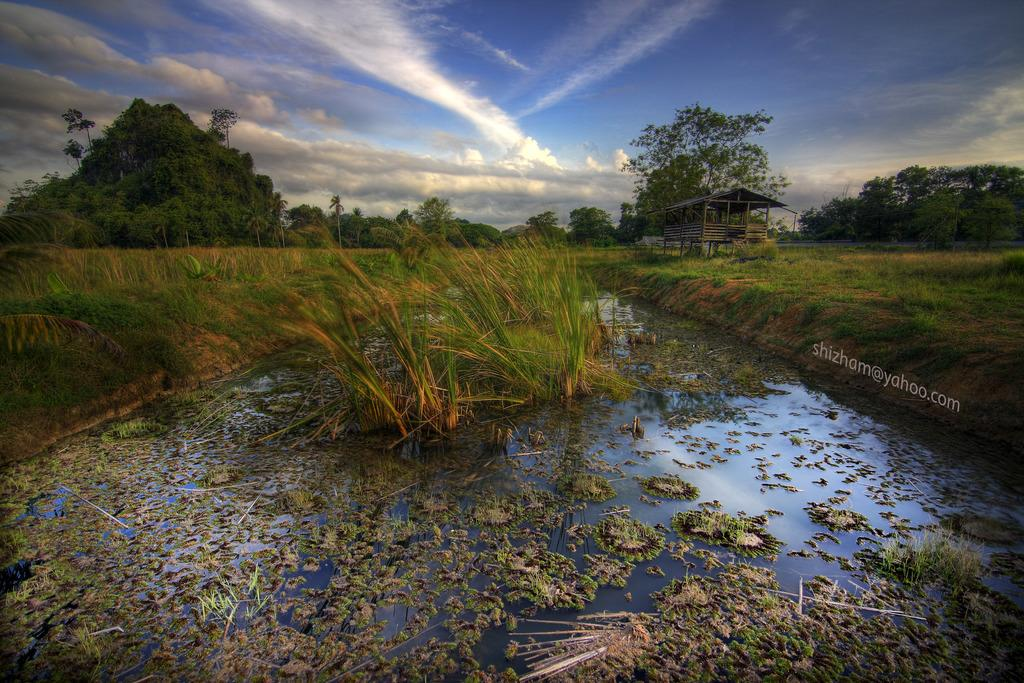What is happening to the plants in the image? The plants are in the water in the image. What can be seen in the background of the image? There are trees, clouds, and a shed visible in the background of the image. What type of jellyfish can be seen swimming in the water with the plants? There are no jellyfish present in the image; it features plants in the water. 